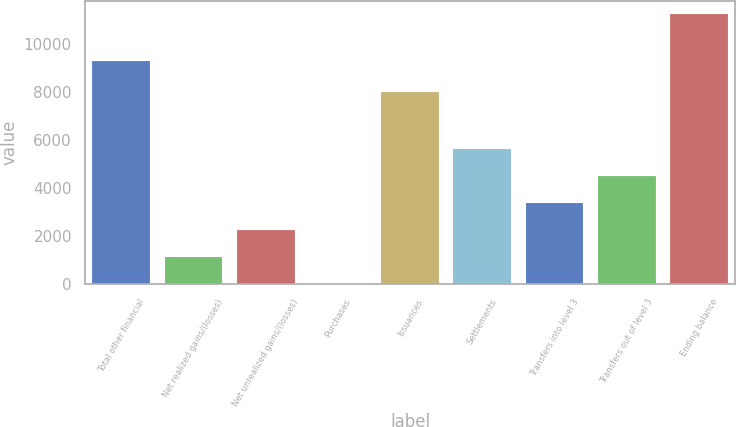<chart> <loc_0><loc_0><loc_500><loc_500><bar_chart><fcel>Total other financial<fcel>Net realized gains/(losses)<fcel>Net unrealized gains/(losses)<fcel>Purchases<fcel>Issuances<fcel>Settlements<fcel>Transfers into level 3<fcel>Transfers out of level 3<fcel>Ending balance<nl><fcel>9292<fcel>1125.3<fcel>2249.6<fcel>1<fcel>8024<fcel>5622.5<fcel>3373.9<fcel>4498.2<fcel>11244<nl></chart> 